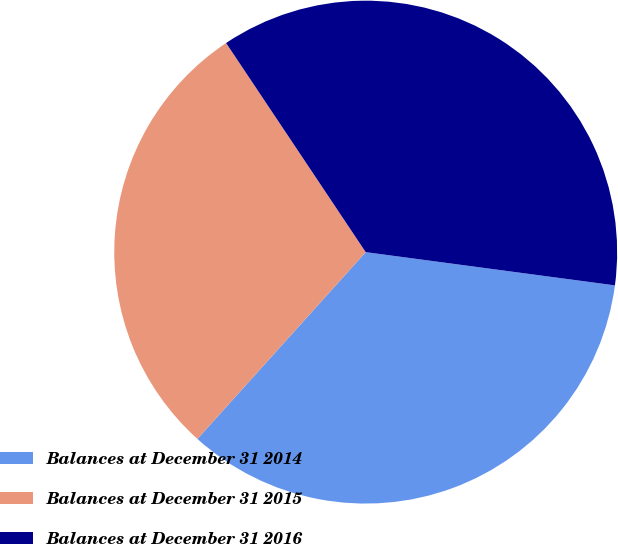<chart> <loc_0><loc_0><loc_500><loc_500><pie_chart><fcel>Balances at December 31 2014<fcel>Balances at December 31 2015<fcel>Balances at December 31 2016<nl><fcel>34.56%<fcel>28.96%<fcel>36.48%<nl></chart> 